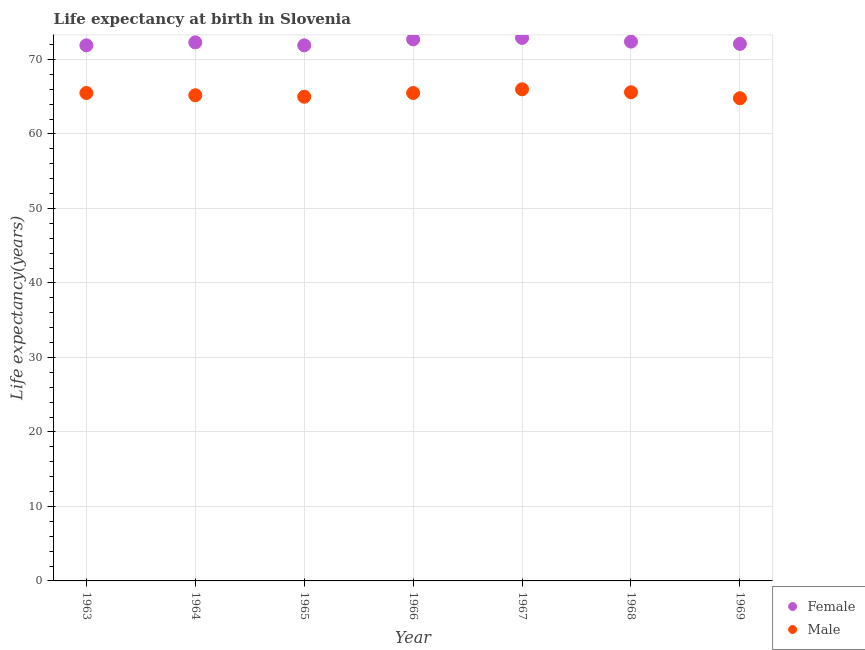What is the life expectancy(female) in 1963?
Ensure brevity in your answer.  71.9. Across all years, what is the maximum life expectancy(female)?
Give a very brief answer. 72.9. Across all years, what is the minimum life expectancy(female)?
Offer a very short reply. 71.9. In which year was the life expectancy(female) maximum?
Your answer should be compact. 1967. In which year was the life expectancy(male) minimum?
Give a very brief answer. 1969. What is the total life expectancy(female) in the graph?
Make the answer very short. 506.2. What is the difference between the life expectancy(female) in 1968 and that in 1969?
Make the answer very short. 0.3. What is the difference between the life expectancy(female) in 1965 and the life expectancy(male) in 1967?
Ensure brevity in your answer.  5.9. What is the average life expectancy(female) per year?
Your answer should be very brief. 72.31. In the year 1963, what is the difference between the life expectancy(female) and life expectancy(male)?
Keep it short and to the point. 6.4. What is the ratio of the life expectancy(female) in 1963 to that in 1969?
Your answer should be very brief. 1. Is the difference between the life expectancy(male) in 1963 and 1964 greater than the difference between the life expectancy(female) in 1963 and 1964?
Provide a short and direct response. Yes. What is the difference between the highest and the second highest life expectancy(male)?
Provide a succinct answer. 0.4. Does the life expectancy(female) monotonically increase over the years?
Ensure brevity in your answer.  No. Is the life expectancy(male) strictly greater than the life expectancy(female) over the years?
Provide a succinct answer. No. Is the life expectancy(male) strictly less than the life expectancy(female) over the years?
Provide a short and direct response. Yes. How many dotlines are there?
Provide a succinct answer. 2. How many years are there in the graph?
Your answer should be compact. 7. What is the difference between two consecutive major ticks on the Y-axis?
Offer a terse response. 10. Does the graph contain any zero values?
Your answer should be compact. No. Does the graph contain grids?
Ensure brevity in your answer.  Yes. What is the title of the graph?
Offer a terse response. Life expectancy at birth in Slovenia. What is the label or title of the X-axis?
Offer a terse response. Year. What is the label or title of the Y-axis?
Provide a short and direct response. Life expectancy(years). What is the Life expectancy(years) in Female in 1963?
Your answer should be very brief. 71.9. What is the Life expectancy(years) in Male in 1963?
Make the answer very short. 65.5. What is the Life expectancy(years) in Female in 1964?
Offer a very short reply. 72.3. What is the Life expectancy(years) of Male in 1964?
Your answer should be very brief. 65.2. What is the Life expectancy(years) in Female in 1965?
Offer a terse response. 71.9. What is the Life expectancy(years) of Male in 1965?
Make the answer very short. 65. What is the Life expectancy(years) in Female in 1966?
Your answer should be compact. 72.7. What is the Life expectancy(years) of Male in 1966?
Provide a short and direct response. 65.5. What is the Life expectancy(years) in Female in 1967?
Offer a very short reply. 72.9. What is the Life expectancy(years) in Female in 1968?
Offer a terse response. 72.4. What is the Life expectancy(years) in Male in 1968?
Keep it short and to the point. 65.6. What is the Life expectancy(years) in Female in 1969?
Provide a succinct answer. 72.1. What is the Life expectancy(years) in Male in 1969?
Keep it short and to the point. 64.8. Across all years, what is the maximum Life expectancy(years) in Female?
Your answer should be compact. 72.9. Across all years, what is the maximum Life expectancy(years) of Male?
Offer a terse response. 66. Across all years, what is the minimum Life expectancy(years) in Female?
Provide a succinct answer. 71.9. Across all years, what is the minimum Life expectancy(years) in Male?
Offer a terse response. 64.8. What is the total Life expectancy(years) of Female in the graph?
Ensure brevity in your answer.  506.2. What is the total Life expectancy(years) of Male in the graph?
Offer a terse response. 457.6. What is the difference between the Life expectancy(years) in Female in 1963 and that in 1964?
Your answer should be compact. -0.4. What is the difference between the Life expectancy(years) of Male in 1963 and that in 1964?
Provide a short and direct response. 0.3. What is the difference between the Life expectancy(years) of Male in 1963 and that in 1965?
Provide a short and direct response. 0.5. What is the difference between the Life expectancy(years) of Male in 1963 and that in 1966?
Ensure brevity in your answer.  0. What is the difference between the Life expectancy(years) of Male in 1963 and that in 1967?
Keep it short and to the point. -0.5. What is the difference between the Life expectancy(years) in Male in 1963 and that in 1968?
Keep it short and to the point. -0.1. What is the difference between the Life expectancy(years) in Female in 1964 and that in 1965?
Offer a very short reply. 0.4. What is the difference between the Life expectancy(years) of Female in 1964 and that in 1966?
Ensure brevity in your answer.  -0.4. What is the difference between the Life expectancy(years) in Male in 1964 and that in 1966?
Ensure brevity in your answer.  -0.3. What is the difference between the Life expectancy(years) of Female in 1964 and that in 1967?
Keep it short and to the point. -0.6. What is the difference between the Life expectancy(years) in Male in 1964 and that in 1967?
Make the answer very short. -0.8. What is the difference between the Life expectancy(years) in Male in 1964 and that in 1968?
Make the answer very short. -0.4. What is the difference between the Life expectancy(years) in Female in 1964 and that in 1969?
Provide a short and direct response. 0.2. What is the difference between the Life expectancy(years) in Female in 1965 and that in 1966?
Make the answer very short. -0.8. What is the difference between the Life expectancy(years) of Male in 1965 and that in 1966?
Your answer should be compact. -0.5. What is the difference between the Life expectancy(years) in Female in 1965 and that in 1967?
Your response must be concise. -1. What is the difference between the Life expectancy(years) in Male in 1965 and that in 1967?
Give a very brief answer. -1. What is the difference between the Life expectancy(years) in Male in 1965 and that in 1968?
Your answer should be very brief. -0.6. What is the difference between the Life expectancy(years) of Female in 1965 and that in 1969?
Offer a very short reply. -0.2. What is the difference between the Life expectancy(years) of Male in 1966 and that in 1967?
Offer a terse response. -0.5. What is the difference between the Life expectancy(years) in Male in 1966 and that in 1968?
Make the answer very short. -0.1. What is the difference between the Life expectancy(years) of Female in 1966 and that in 1969?
Your response must be concise. 0.6. What is the difference between the Life expectancy(years) in Male in 1966 and that in 1969?
Provide a succinct answer. 0.7. What is the difference between the Life expectancy(years) of Female in 1967 and that in 1968?
Keep it short and to the point. 0.5. What is the difference between the Life expectancy(years) of Female in 1967 and that in 1969?
Keep it short and to the point. 0.8. What is the difference between the Life expectancy(years) in Female in 1968 and that in 1969?
Offer a terse response. 0.3. What is the difference between the Life expectancy(years) of Male in 1968 and that in 1969?
Make the answer very short. 0.8. What is the difference between the Life expectancy(years) of Female in 1963 and the Life expectancy(years) of Male in 1964?
Provide a short and direct response. 6.7. What is the difference between the Life expectancy(years) in Female in 1963 and the Life expectancy(years) in Male in 1966?
Offer a terse response. 6.4. What is the difference between the Life expectancy(years) in Female in 1963 and the Life expectancy(years) in Male in 1968?
Keep it short and to the point. 6.3. What is the difference between the Life expectancy(years) of Female in 1964 and the Life expectancy(years) of Male in 1966?
Ensure brevity in your answer.  6.8. What is the difference between the Life expectancy(years) of Female in 1964 and the Life expectancy(years) of Male in 1968?
Provide a succinct answer. 6.7. What is the difference between the Life expectancy(years) of Female in 1965 and the Life expectancy(years) of Male in 1969?
Ensure brevity in your answer.  7.1. What is the difference between the Life expectancy(years) of Female in 1966 and the Life expectancy(years) of Male in 1968?
Offer a terse response. 7.1. What is the difference between the Life expectancy(years) of Female in 1967 and the Life expectancy(years) of Male in 1968?
Your answer should be compact. 7.3. What is the average Life expectancy(years) in Female per year?
Provide a succinct answer. 72.31. What is the average Life expectancy(years) in Male per year?
Give a very brief answer. 65.37. In the year 1963, what is the difference between the Life expectancy(years) in Female and Life expectancy(years) in Male?
Offer a terse response. 6.4. In the year 1966, what is the difference between the Life expectancy(years) of Female and Life expectancy(years) of Male?
Make the answer very short. 7.2. In the year 1968, what is the difference between the Life expectancy(years) of Female and Life expectancy(years) of Male?
Make the answer very short. 6.8. What is the ratio of the Life expectancy(years) of Male in 1963 to that in 1965?
Give a very brief answer. 1.01. What is the ratio of the Life expectancy(years) of Female in 1963 to that in 1967?
Give a very brief answer. 0.99. What is the ratio of the Life expectancy(years) of Male in 1963 to that in 1967?
Your answer should be very brief. 0.99. What is the ratio of the Life expectancy(years) in Female in 1963 to that in 1968?
Offer a very short reply. 0.99. What is the ratio of the Life expectancy(years) of Male in 1963 to that in 1969?
Your answer should be compact. 1.01. What is the ratio of the Life expectancy(years) in Female in 1964 to that in 1965?
Provide a succinct answer. 1.01. What is the ratio of the Life expectancy(years) of Male in 1964 to that in 1965?
Provide a succinct answer. 1. What is the ratio of the Life expectancy(years) of Female in 1964 to that in 1966?
Give a very brief answer. 0.99. What is the ratio of the Life expectancy(years) in Male in 1964 to that in 1966?
Keep it short and to the point. 1. What is the ratio of the Life expectancy(years) of Male in 1964 to that in 1967?
Ensure brevity in your answer.  0.99. What is the ratio of the Life expectancy(years) in Male in 1964 to that in 1968?
Make the answer very short. 0.99. What is the ratio of the Life expectancy(years) of Male in 1964 to that in 1969?
Make the answer very short. 1.01. What is the ratio of the Life expectancy(years) in Male in 1965 to that in 1966?
Give a very brief answer. 0.99. What is the ratio of the Life expectancy(years) in Female in 1965 to that in 1967?
Offer a very short reply. 0.99. What is the ratio of the Life expectancy(years) in Male in 1965 to that in 1967?
Provide a short and direct response. 0.98. What is the ratio of the Life expectancy(years) in Female in 1965 to that in 1968?
Your answer should be compact. 0.99. What is the ratio of the Life expectancy(years) in Male in 1965 to that in 1968?
Give a very brief answer. 0.99. What is the ratio of the Life expectancy(years) of Female in 1965 to that in 1969?
Provide a short and direct response. 1. What is the ratio of the Life expectancy(years) of Male in 1965 to that in 1969?
Your answer should be very brief. 1. What is the ratio of the Life expectancy(years) in Female in 1966 to that in 1967?
Provide a succinct answer. 1. What is the ratio of the Life expectancy(years) of Female in 1966 to that in 1969?
Ensure brevity in your answer.  1.01. What is the ratio of the Life expectancy(years) in Male in 1966 to that in 1969?
Ensure brevity in your answer.  1.01. What is the ratio of the Life expectancy(years) in Female in 1967 to that in 1968?
Your answer should be compact. 1.01. What is the ratio of the Life expectancy(years) of Female in 1967 to that in 1969?
Your answer should be very brief. 1.01. What is the ratio of the Life expectancy(years) of Male in 1967 to that in 1969?
Offer a terse response. 1.02. What is the ratio of the Life expectancy(years) of Female in 1968 to that in 1969?
Make the answer very short. 1. What is the ratio of the Life expectancy(years) of Male in 1968 to that in 1969?
Your answer should be compact. 1.01. What is the difference between the highest and the lowest Life expectancy(years) of Female?
Provide a succinct answer. 1. 